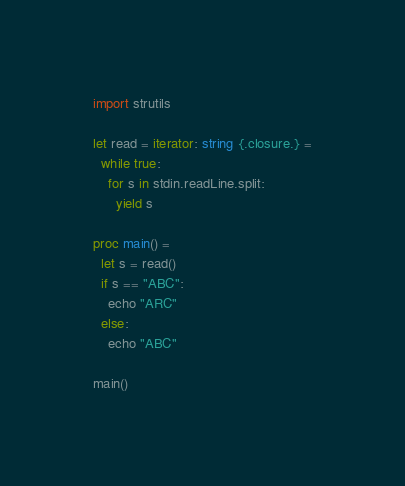<code> <loc_0><loc_0><loc_500><loc_500><_Nim_>import strutils

let read = iterator: string {.closure.} =
  while true:
    for s in stdin.readLine.split:
      yield s

proc main() =
  let s = read()
  if s == "ABC":
    echo "ARC"
  else:
    echo "ABC"

main()</code> 